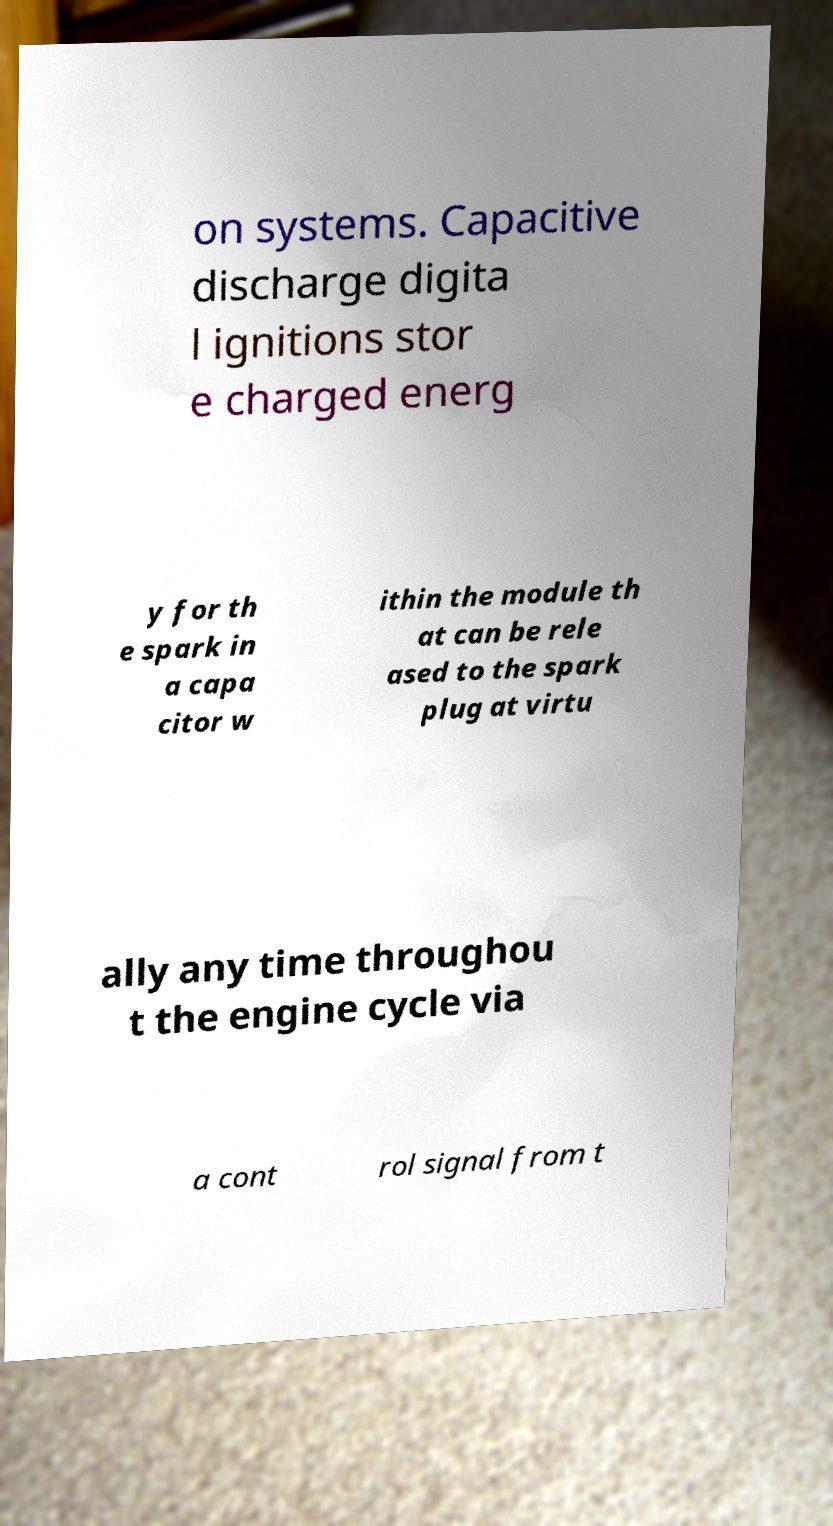I need the written content from this picture converted into text. Can you do that? on systems. Capacitive discharge digita l ignitions stor e charged energ y for th e spark in a capa citor w ithin the module th at can be rele ased to the spark plug at virtu ally any time throughou t the engine cycle via a cont rol signal from t 